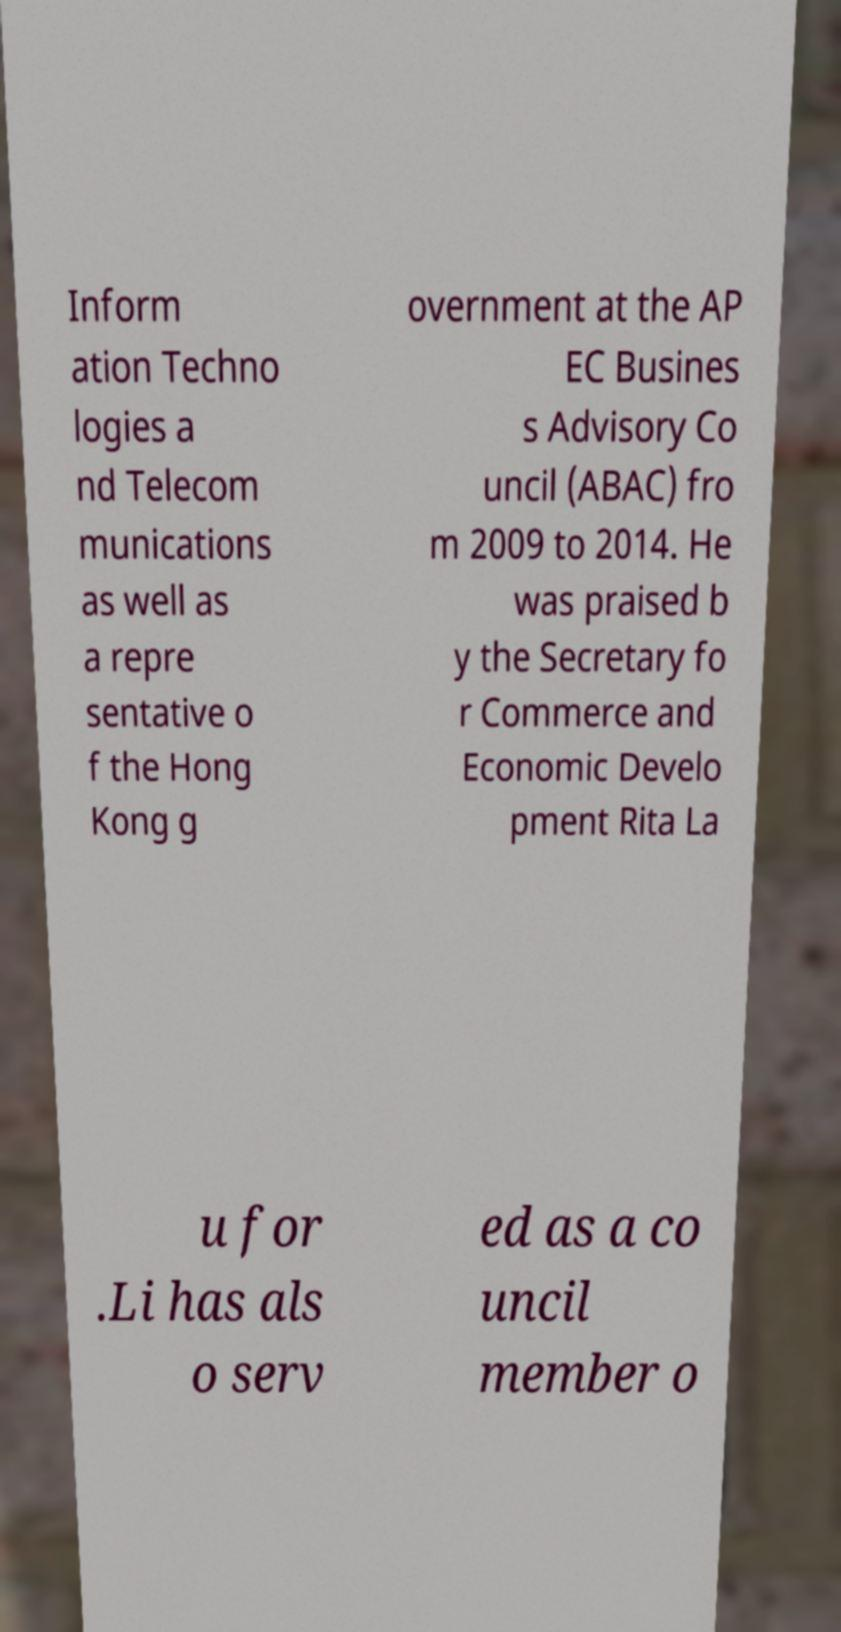For documentation purposes, I need the text within this image transcribed. Could you provide that? Inform ation Techno logies a nd Telecom munications as well as a repre sentative o f the Hong Kong g overnment at the AP EC Busines s Advisory Co uncil (ABAC) fro m 2009 to 2014. He was praised b y the Secretary fo r Commerce and Economic Develo pment Rita La u for .Li has als o serv ed as a co uncil member o 